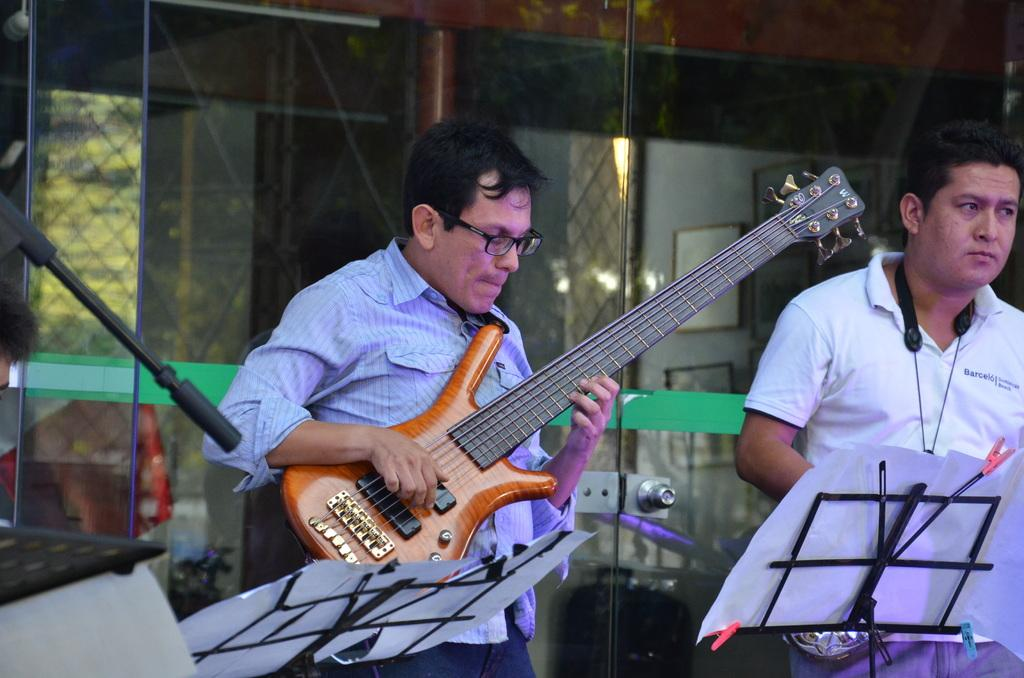How many people are in the image? There are two persons in the image. What is one of the persons doing in the image? One of the persons is playing a guitar. What type of card is being used by the person playing the guitar in the image? There is no card present in the image; the person is playing a guitar. What kind of furniture can be seen in the image? There is no furniture visible in the image; it only features two persons, one of whom is playing a guitar. 